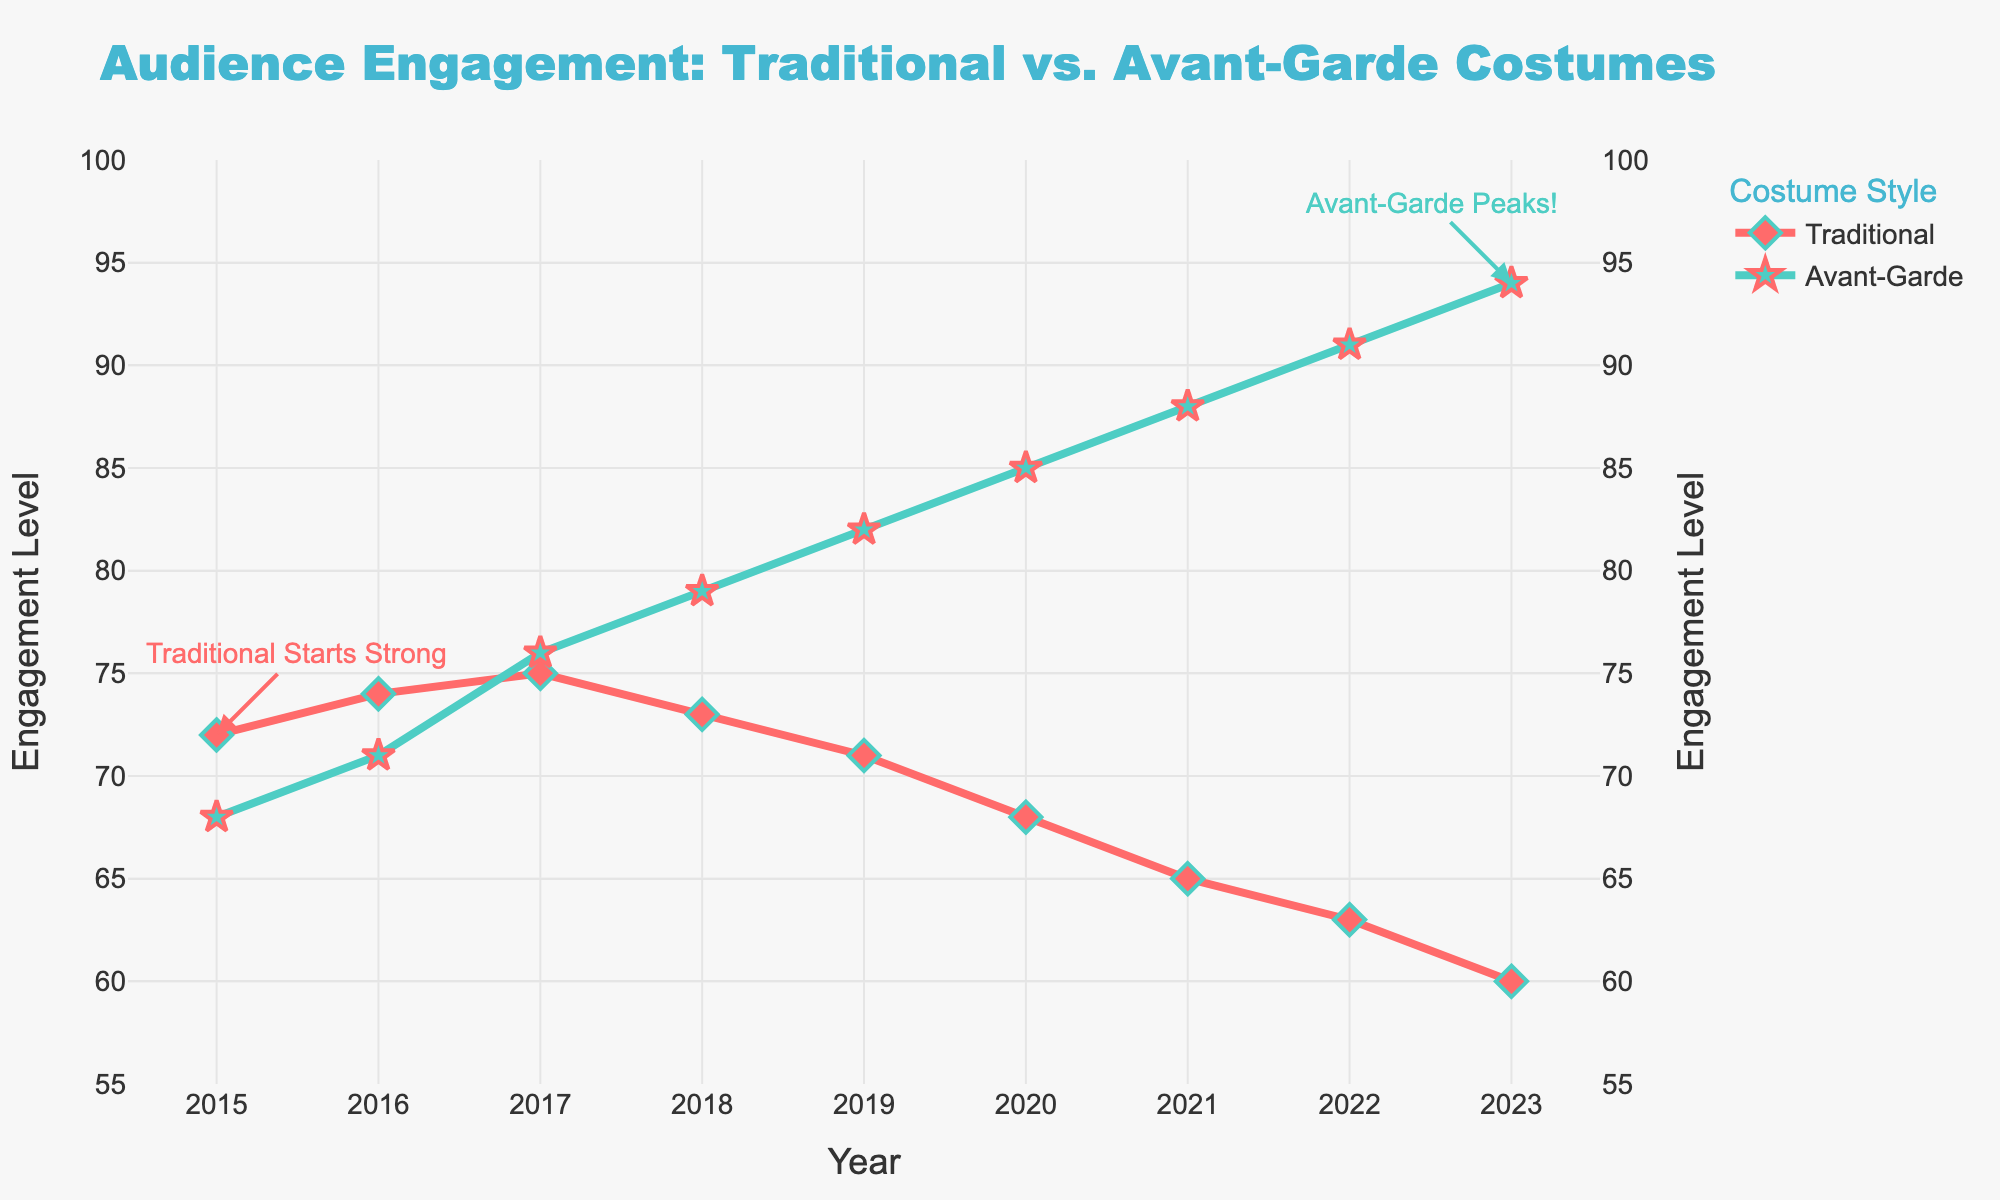What is the trend in audience engagement levels for traditional costumes from 2015 to 2023? From the figure, the engagement levels for traditional costumes start at 72 in 2015 and gradually decrease to 60 in 2023. This indicates a downward trend.
Answer: Downward trend In which year does the audience engagement level for avant-garde costumes surpass traditional ones? The engagement level for avant-garde costumes surpasses traditional ones in 2017, where avant-garde reaches 76 and traditional stays at 75.
Answer: 2017 By how many points did the engagement level for avant-garde costumes increase from 2015 to 2023? The engagement level for avant-garde costumes increases from 68 in 2015 to 94 in 2023. The increase is 94 - 68.
Answer: 26 points In 2018, how does the engagement level for avant-garde costumes compare to that of traditional ones? In 2018, the engagement level for avant-garde costumes is 79, while for traditional it is 73. Avant-garde costumes have higher engagement.
Answer: Higher What is the overall average engagement level for traditional costumes from 2015 to 2023? The engagement levels from 2015 to 2023 for traditional costumes are 72, 74, 75, 73, 71, 68, 65, 63, and 60. The average is (72+74+75+73+71+68+65+63+60)/9.
Answer: 68.9 What visual attribute is used to highlight the peaks and start points in the figure? The figure uses annotations with arrows to highlight these points, with text labels and arrows pointing to the specific data markers.
Answer: Annotations with arrows By 2023, how much higher is the engagement level for avant-garde costumes compared to traditional costumes? In 2023, the engagement level for avant-garde costumes is 94, while for traditional it is 60. The difference is 94 - 60.
Answer: 34 points Which year shows the highest engagement level for avant-garde costumes? The highest engagement level for avant-garde costumes is in 2023, with a value of 94.
Answer: 2023 What colors are used to differentiate between traditional and avant-garde costume engagement levels in the plot? Traditional costume engagement levels are represented in red, whereas avant-garde costume engagement levels are in green.
Answer: Red and green Which costume type starts with higher engagement in 2015 and how does it change by 2023? In 2015, traditional costumes start with higher engagement at 72 compared to avant-garde at 68. By 2023, avant-garde engagement increases to 94, surpassing the traditional which drops to 60.
Answer: Traditional starts higher, changes to avant-garde higher 